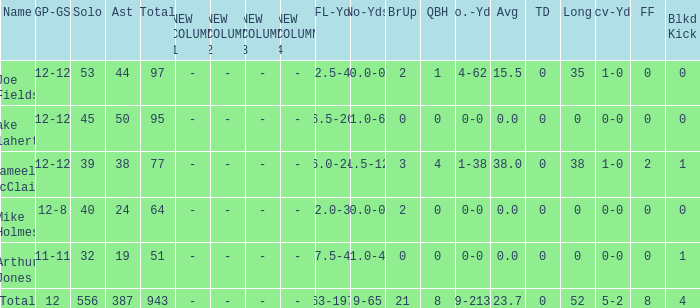How many tackle assists for the player who averages 23.7? 387.0. 